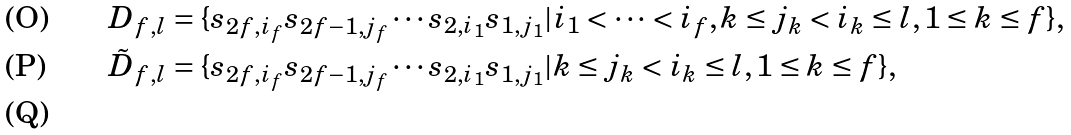<formula> <loc_0><loc_0><loc_500><loc_500>D _ { f , l } & = \{ s _ { 2 f , i _ { f } } s _ { 2 f - 1 , j _ { f } } \cdots s _ { 2 , i _ { 1 } } s _ { 1 , j _ { 1 } } | i _ { 1 } < \dots < i _ { f } , k \leq j _ { k } < i _ { k } \leq l , 1 \leq k \leq f \} , \\ \tilde { D } _ { f , l } & = \{ s _ { 2 f , i _ { f } } s _ { 2 f - 1 , j _ { f } } \cdots s _ { 2 , i _ { 1 } } s _ { 1 , j _ { 1 } } | k \leq j _ { k } < i _ { k } \leq l , 1 \leq k \leq f \} , \\</formula> 